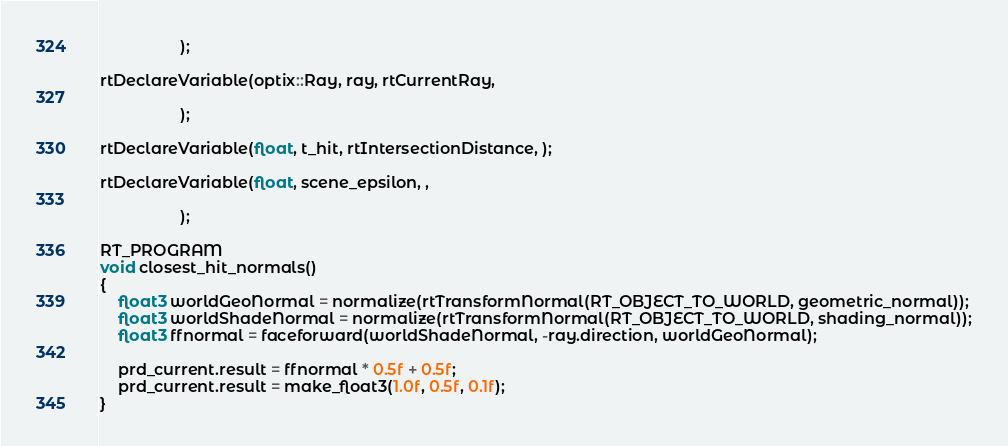<code> <loc_0><loc_0><loc_500><loc_500><_Cuda_>
                  );

rtDeclareVariable(optix::Ray, ray, rtCurrentRay,

                  );

rtDeclareVariable(float, t_hit, rtIntersectionDistance, );

rtDeclareVariable(float, scene_epsilon, ,

                  );

RT_PROGRAM
void closest_hit_normals()
{
    float3 worldGeoNormal = normalize(rtTransformNormal(RT_OBJECT_TO_WORLD, geometric_normal));
    float3 worldShadeNormal = normalize(rtTransformNormal(RT_OBJECT_TO_WORLD, shading_normal));
    float3 ffnormal = faceforward(worldShadeNormal, -ray.direction, worldGeoNormal);

    prd_current.result = ffnormal * 0.5f + 0.5f;
    prd_current.result = make_float3(1.0f, 0.5f, 0.1f);
}
</code> 